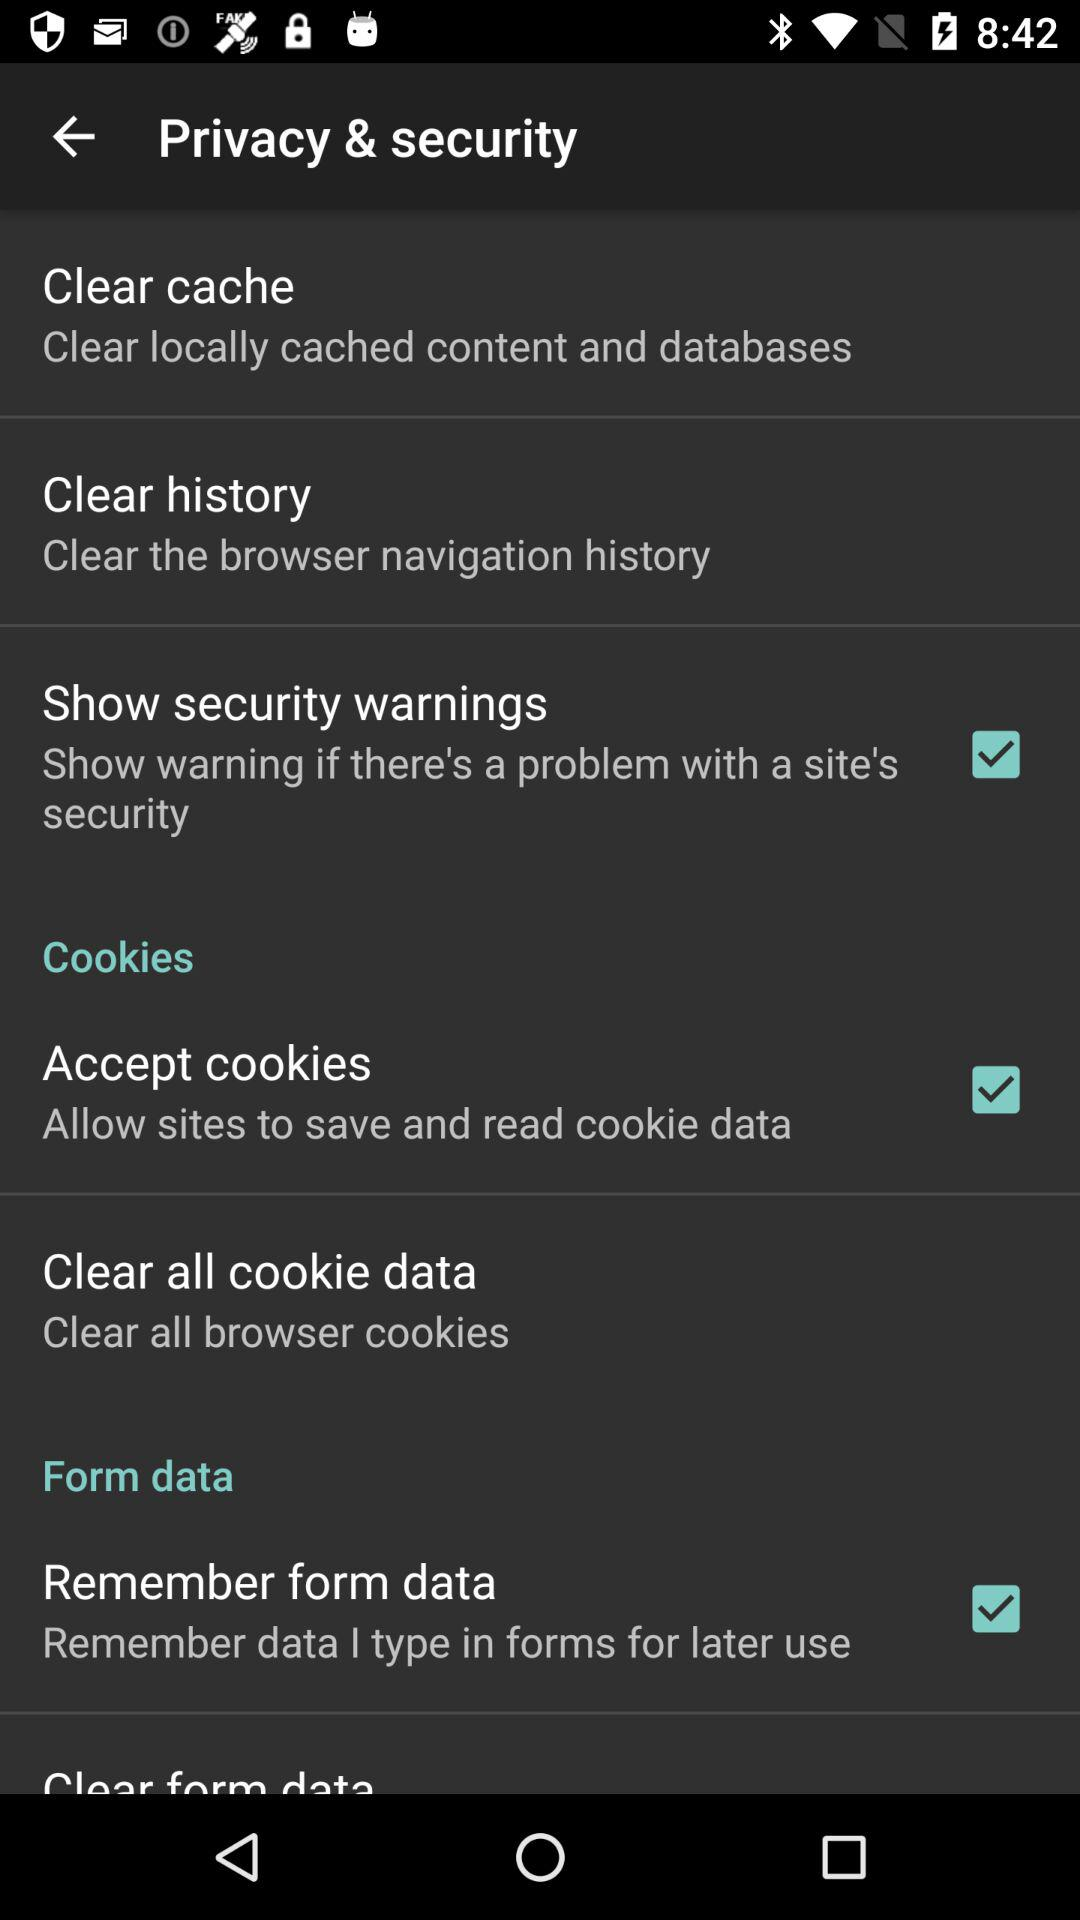When will the user be warned about security? The user will be warned about security if there's a problem with a site's security. 